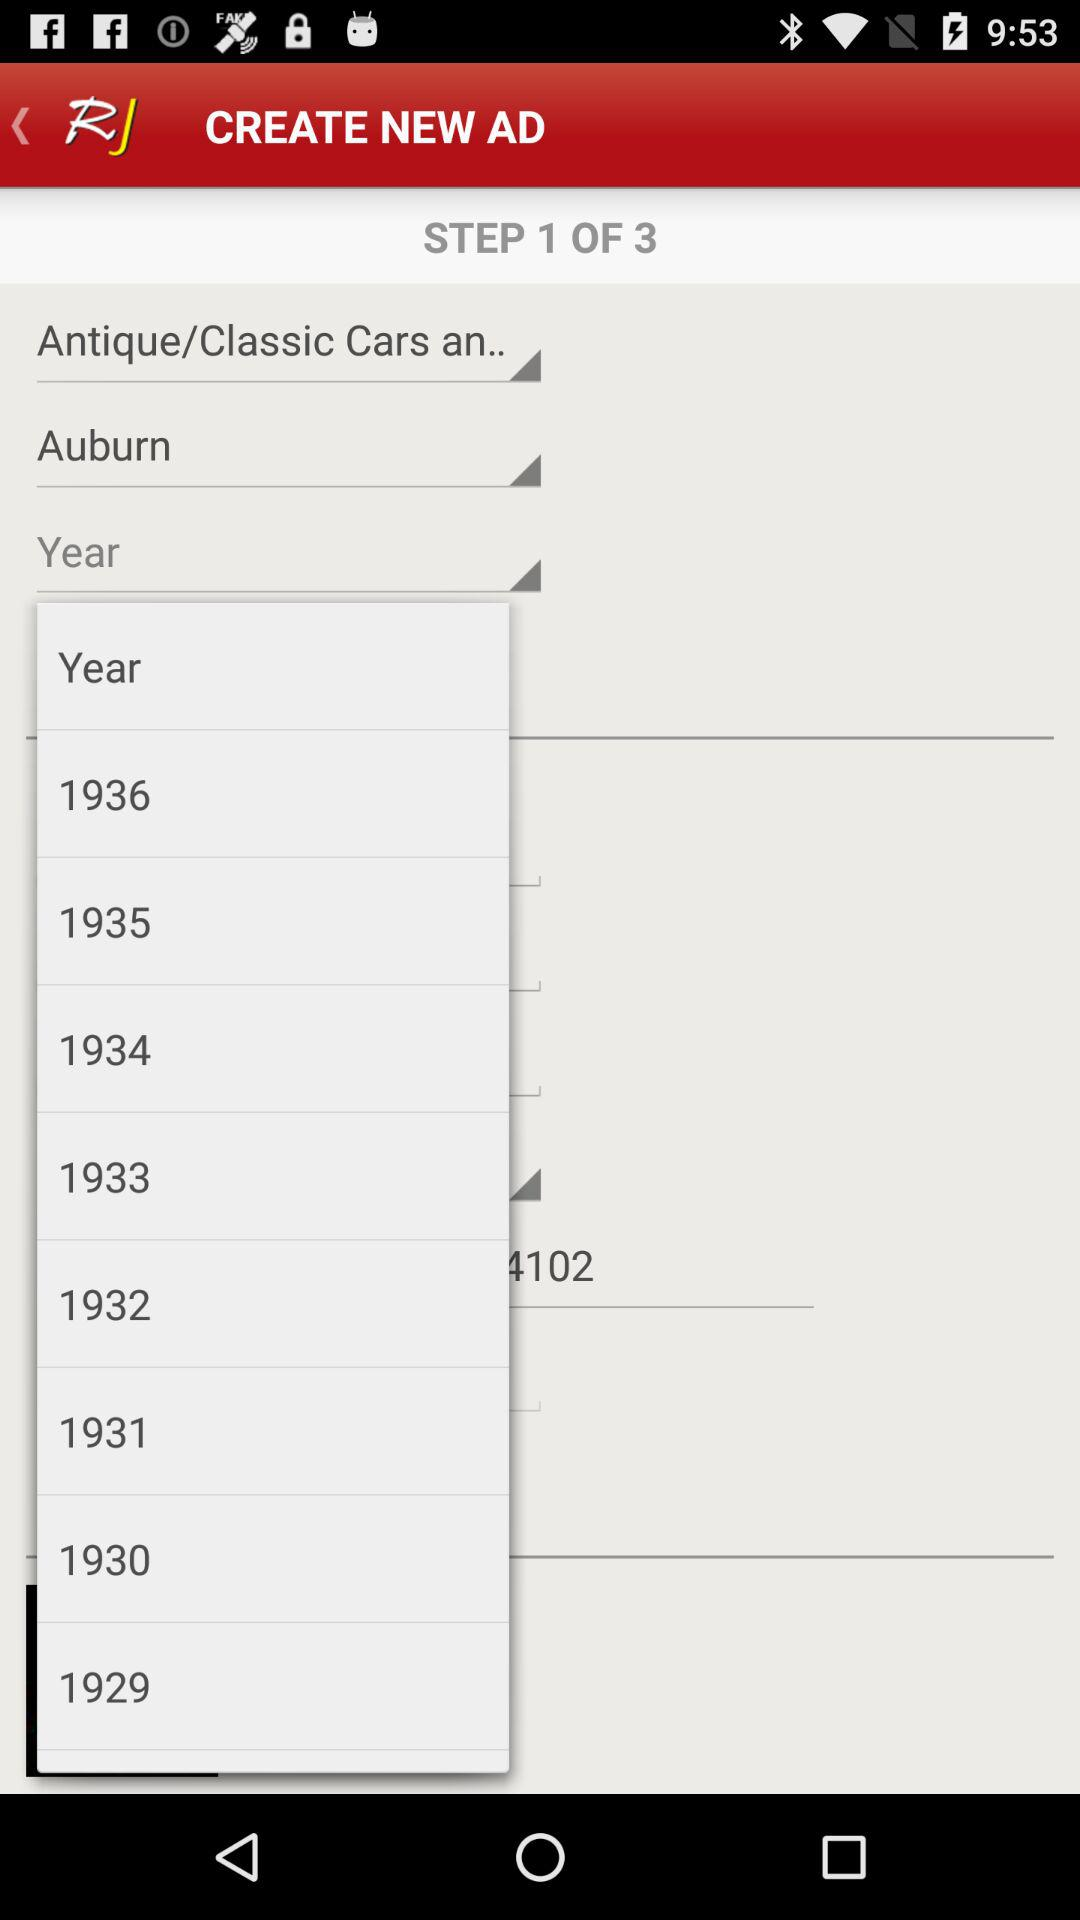How many steps in total are there? There are 3 pages. 